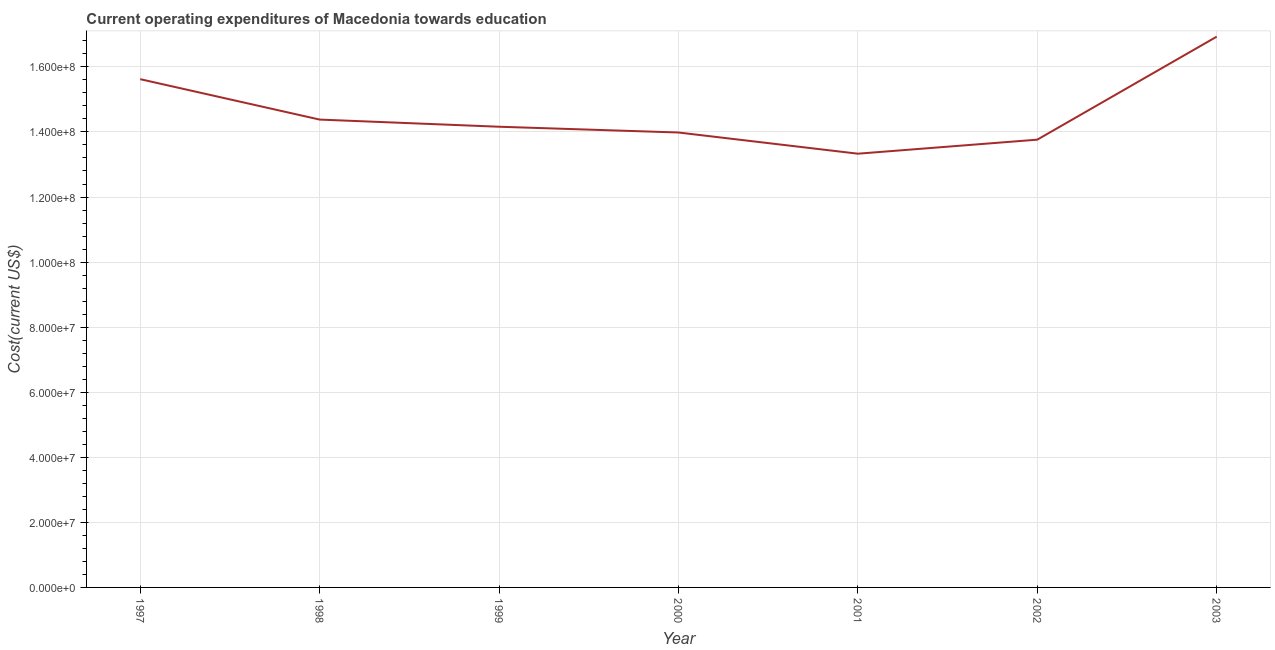What is the education expenditure in 2000?
Give a very brief answer. 1.40e+08. Across all years, what is the maximum education expenditure?
Ensure brevity in your answer.  1.69e+08. Across all years, what is the minimum education expenditure?
Your answer should be very brief. 1.33e+08. In which year was the education expenditure maximum?
Offer a very short reply. 2003. In which year was the education expenditure minimum?
Provide a succinct answer. 2001. What is the sum of the education expenditure?
Your answer should be very brief. 1.02e+09. What is the difference between the education expenditure in 1997 and 2000?
Keep it short and to the point. 1.64e+07. What is the average education expenditure per year?
Provide a short and direct response. 1.46e+08. What is the median education expenditure?
Give a very brief answer. 1.42e+08. In how many years, is the education expenditure greater than 112000000 US$?
Provide a short and direct response. 7. What is the ratio of the education expenditure in 1997 to that in 2000?
Keep it short and to the point. 1.12. What is the difference between the highest and the second highest education expenditure?
Offer a terse response. 1.31e+07. What is the difference between the highest and the lowest education expenditure?
Ensure brevity in your answer.  3.60e+07. In how many years, is the education expenditure greater than the average education expenditure taken over all years?
Offer a very short reply. 2. Does the education expenditure monotonically increase over the years?
Your answer should be compact. No. How many lines are there?
Your answer should be compact. 1. What is the difference between two consecutive major ticks on the Y-axis?
Ensure brevity in your answer.  2.00e+07. Are the values on the major ticks of Y-axis written in scientific E-notation?
Offer a terse response. Yes. Does the graph contain any zero values?
Your answer should be very brief. No. Does the graph contain grids?
Give a very brief answer. Yes. What is the title of the graph?
Make the answer very short. Current operating expenditures of Macedonia towards education. What is the label or title of the Y-axis?
Provide a short and direct response. Cost(current US$). What is the Cost(current US$) of 1997?
Your answer should be compact. 1.56e+08. What is the Cost(current US$) of 1998?
Provide a succinct answer. 1.44e+08. What is the Cost(current US$) in 1999?
Provide a succinct answer. 1.42e+08. What is the Cost(current US$) of 2000?
Make the answer very short. 1.40e+08. What is the Cost(current US$) of 2001?
Offer a terse response. 1.33e+08. What is the Cost(current US$) in 2002?
Offer a very short reply. 1.38e+08. What is the Cost(current US$) in 2003?
Offer a very short reply. 1.69e+08. What is the difference between the Cost(current US$) in 1997 and 1998?
Your answer should be very brief. 1.24e+07. What is the difference between the Cost(current US$) in 1997 and 1999?
Your answer should be compact. 1.46e+07. What is the difference between the Cost(current US$) in 1997 and 2000?
Offer a very short reply. 1.64e+07. What is the difference between the Cost(current US$) in 1997 and 2001?
Offer a very short reply. 2.29e+07. What is the difference between the Cost(current US$) in 1997 and 2002?
Provide a succinct answer. 1.86e+07. What is the difference between the Cost(current US$) in 1997 and 2003?
Provide a short and direct response. -1.31e+07. What is the difference between the Cost(current US$) in 1998 and 1999?
Ensure brevity in your answer.  2.20e+06. What is the difference between the Cost(current US$) in 1998 and 2000?
Offer a terse response. 3.97e+06. What is the difference between the Cost(current US$) in 1998 and 2001?
Your answer should be compact. 1.05e+07. What is the difference between the Cost(current US$) in 1998 and 2002?
Offer a terse response. 6.17e+06. What is the difference between the Cost(current US$) in 1998 and 2003?
Your answer should be very brief. -2.55e+07. What is the difference between the Cost(current US$) in 1999 and 2000?
Your answer should be very brief. 1.77e+06. What is the difference between the Cost(current US$) in 1999 and 2001?
Provide a short and direct response. 8.29e+06. What is the difference between the Cost(current US$) in 1999 and 2002?
Ensure brevity in your answer.  3.97e+06. What is the difference between the Cost(current US$) in 1999 and 2003?
Your answer should be very brief. -2.77e+07. What is the difference between the Cost(current US$) in 2000 and 2001?
Your answer should be compact. 6.51e+06. What is the difference between the Cost(current US$) in 2000 and 2002?
Your answer should be compact. 2.20e+06. What is the difference between the Cost(current US$) in 2000 and 2003?
Keep it short and to the point. -2.95e+07. What is the difference between the Cost(current US$) in 2001 and 2002?
Keep it short and to the point. -4.31e+06. What is the difference between the Cost(current US$) in 2001 and 2003?
Your response must be concise. -3.60e+07. What is the difference between the Cost(current US$) in 2002 and 2003?
Make the answer very short. -3.17e+07. What is the ratio of the Cost(current US$) in 1997 to that in 1998?
Your response must be concise. 1.09. What is the ratio of the Cost(current US$) in 1997 to that in 1999?
Your answer should be compact. 1.1. What is the ratio of the Cost(current US$) in 1997 to that in 2000?
Your response must be concise. 1.12. What is the ratio of the Cost(current US$) in 1997 to that in 2001?
Offer a terse response. 1.17. What is the ratio of the Cost(current US$) in 1997 to that in 2002?
Your answer should be very brief. 1.14. What is the ratio of the Cost(current US$) in 1997 to that in 2003?
Your answer should be compact. 0.92. What is the ratio of the Cost(current US$) in 1998 to that in 2000?
Your answer should be compact. 1.03. What is the ratio of the Cost(current US$) in 1998 to that in 2001?
Your answer should be compact. 1.08. What is the ratio of the Cost(current US$) in 1998 to that in 2002?
Your answer should be compact. 1.04. What is the ratio of the Cost(current US$) in 1998 to that in 2003?
Give a very brief answer. 0.85. What is the ratio of the Cost(current US$) in 1999 to that in 2000?
Your response must be concise. 1.01. What is the ratio of the Cost(current US$) in 1999 to that in 2001?
Make the answer very short. 1.06. What is the ratio of the Cost(current US$) in 1999 to that in 2002?
Your answer should be compact. 1.03. What is the ratio of the Cost(current US$) in 1999 to that in 2003?
Offer a very short reply. 0.84. What is the ratio of the Cost(current US$) in 2000 to that in 2001?
Keep it short and to the point. 1.05. What is the ratio of the Cost(current US$) in 2000 to that in 2003?
Your response must be concise. 0.83. What is the ratio of the Cost(current US$) in 2001 to that in 2003?
Provide a succinct answer. 0.79. What is the ratio of the Cost(current US$) in 2002 to that in 2003?
Your answer should be very brief. 0.81. 